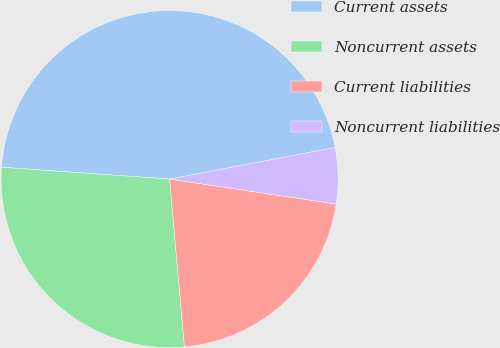Convert chart. <chart><loc_0><loc_0><loc_500><loc_500><pie_chart><fcel>Current assets<fcel>Noncurrent assets<fcel>Current liabilities<fcel>Noncurrent liabilities<nl><fcel>45.87%<fcel>27.52%<fcel>21.23%<fcel>5.37%<nl></chart> 